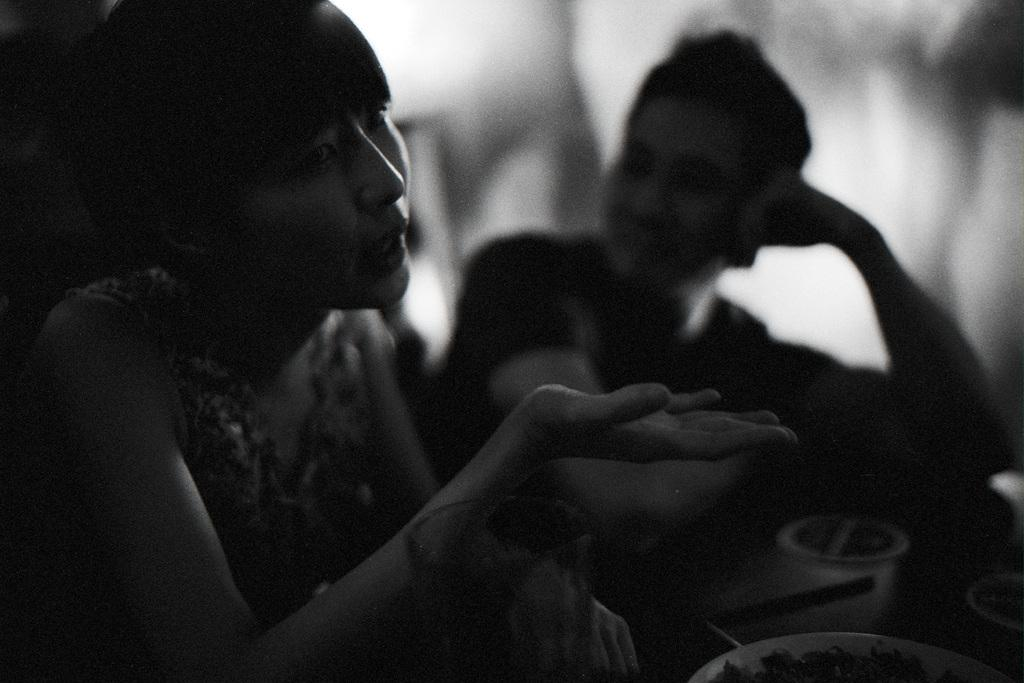What is the color scheme of the image? The image is black and white. Can you describe the people in the image? There are people in the image, but their specific characteristics are not mentioned in the facts. What type of food is on the plate in the image? The facts do not specify the type of food on the plate. What other objects are present in the image besides the people and the plate of food? There are other objects present in the image, but their specific details are not mentioned in the facts. How much respect is shown by the celery in the image? There is no celery present in the image, so it is not possible to determine the level of respect shown by any celery. 